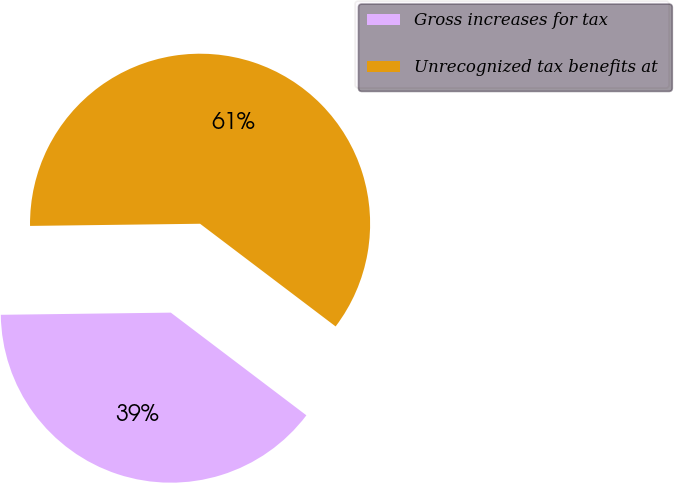Convert chart to OTSL. <chart><loc_0><loc_0><loc_500><loc_500><pie_chart><fcel>Gross increases for tax<fcel>Unrecognized tax benefits at<nl><fcel>39.48%<fcel>60.52%<nl></chart> 